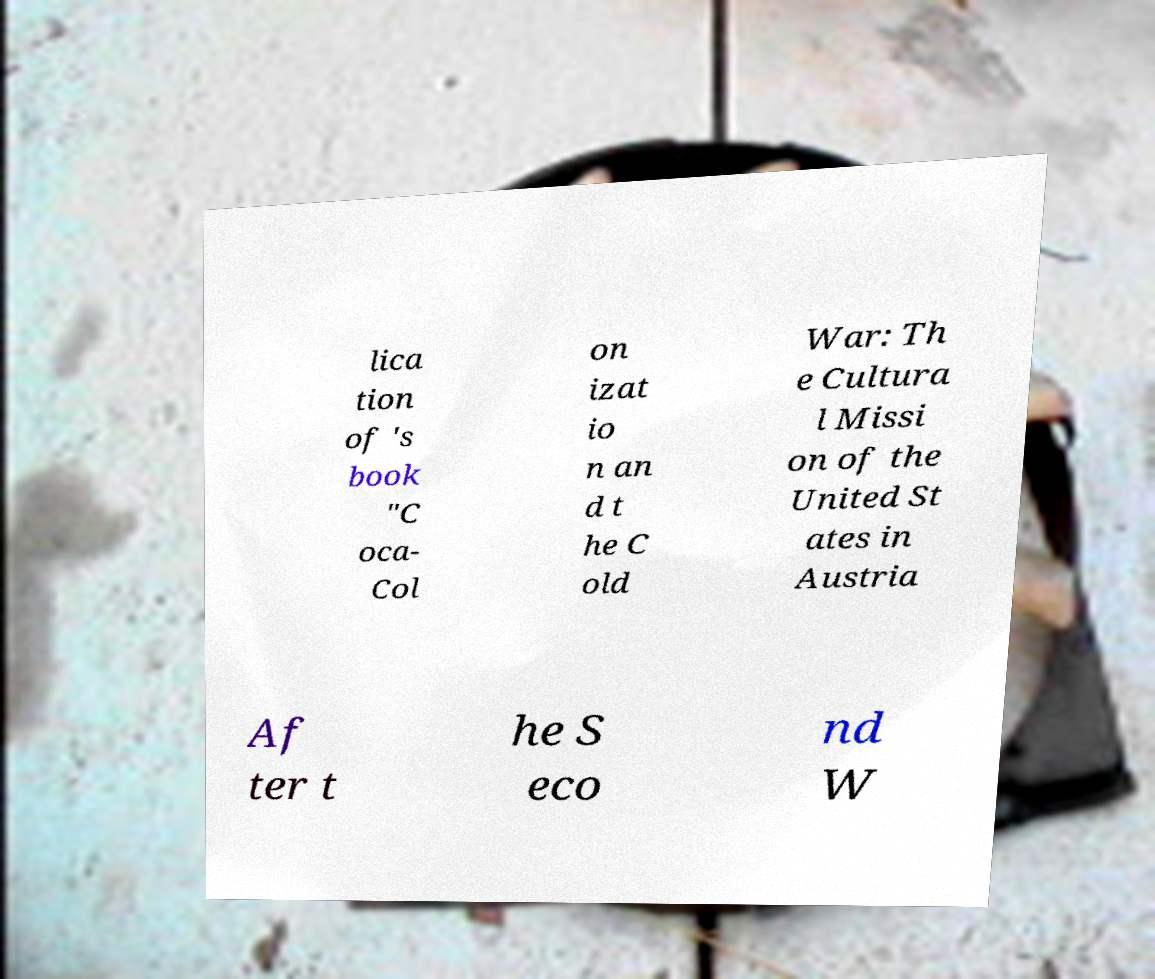What messages or text are displayed in this image? I need them in a readable, typed format. lica tion of 's book "C oca- Col on izat io n an d t he C old War: Th e Cultura l Missi on of the United St ates in Austria Af ter t he S eco nd W 